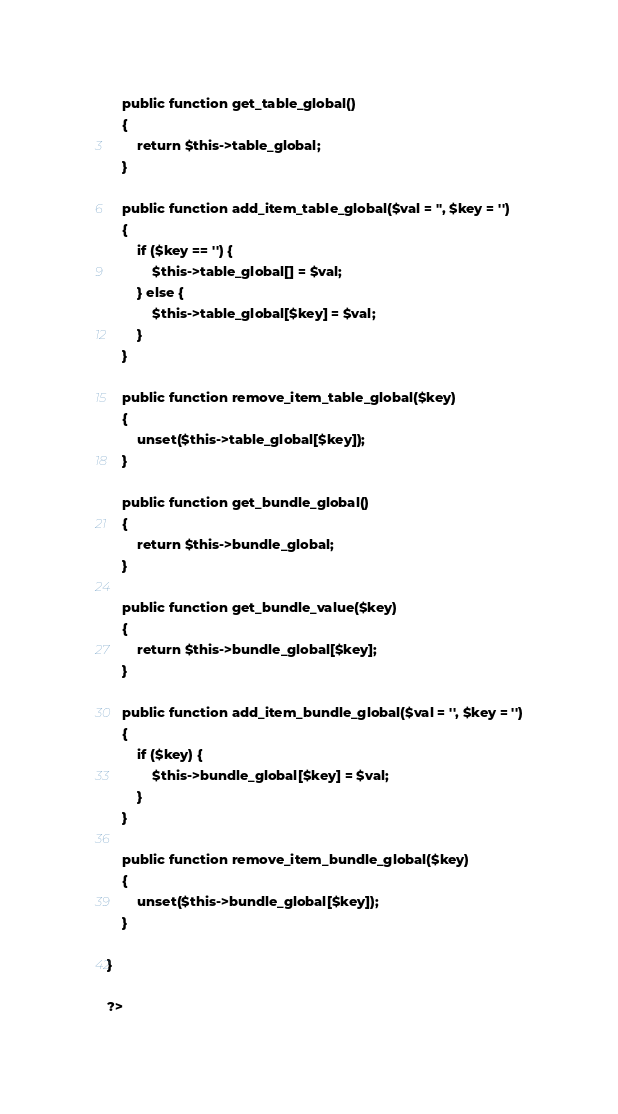Convert code to text. <code><loc_0><loc_0><loc_500><loc_500><_PHP_>    public function get_table_global()
    {
        return $this->table_global;
    }

    public function add_item_table_global($val = '', $key = '')
    {
        if ($key == '') {
            $this->table_global[] = $val;
        } else {
            $this->table_global[$key] = $val;
        }
    }

    public function remove_item_table_global($key)
    {
        unset($this->table_global[$key]);
    }

    public function get_bundle_global()
    {
        return $this->bundle_global;
    }

    public function get_bundle_value($key)
    {
        return $this->bundle_global[$key];
    }

    public function add_item_bundle_global($val = '', $key = '')
    {
        if ($key) {
            $this->bundle_global[$key] = $val;
        }
    }

    public function remove_item_bundle_global($key)
    {
        unset($this->bundle_global[$key]);
    }

}

?></code> 